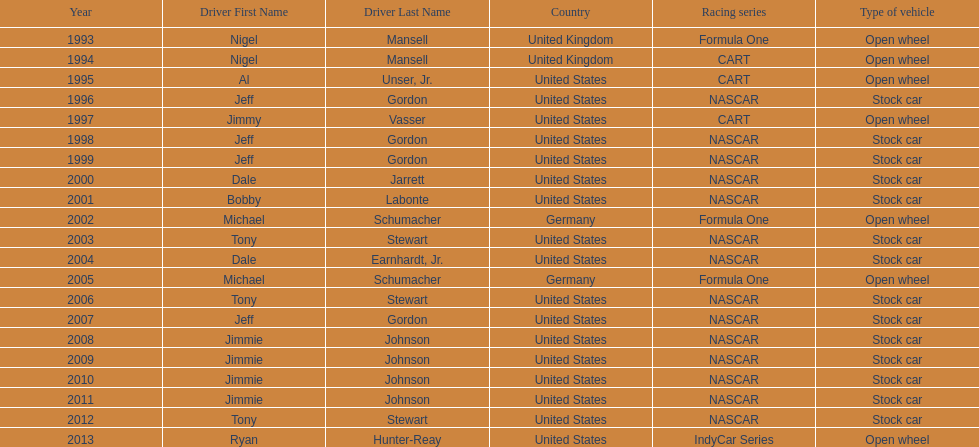Write the full table. {'header': ['Year', 'Driver First Name', 'Driver Last Name', 'Country', 'Racing series', 'Type of vehicle'], 'rows': [['1993', 'Nigel', 'Mansell', 'United Kingdom', 'Formula One', 'Open wheel'], ['1994', 'Nigel', 'Mansell', 'United Kingdom', 'CART', 'Open wheel'], ['1995', 'Al', 'Unser, Jr.', 'United States', 'CART', 'Open wheel'], ['1996', 'Jeff', 'Gordon', 'United States', 'NASCAR', 'Stock car'], ['1997', 'Jimmy', 'Vasser', 'United States', 'CART', 'Open wheel'], ['1998', 'Jeff', 'Gordon', 'United States', 'NASCAR', 'Stock car'], ['1999', 'Jeff', 'Gordon', 'United States', 'NASCAR', 'Stock car'], ['2000', 'Dale', 'Jarrett', 'United States', 'NASCAR', 'Stock car'], ['2001', 'Bobby', 'Labonte', 'United States', 'NASCAR', 'Stock car'], ['2002', 'Michael', 'Schumacher', 'Germany', 'Formula One', 'Open wheel'], ['2003', 'Tony', 'Stewart', 'United States', 'NASCAR', 'Stock car'], ['2004', 'Dale', 'Earnhardt, Jr.', 'United States', 'NASCAR', 'Stock car'], ['2005', 'Michael', 'Schumacher', 'Germany', 'Formula One', 'Open wheel'], ['2006', 'Tony', 'Stewart', 'United States', 'NASCAR', 'Stock car'], ['2007', 'Jeff', 'Gordon', 'United States', 'NASCAR', 'Stock car'], ['2008', 'Jimmie', 'Johnson', 'United States', 'NASCAR', 'Stock car'], ['2009', 'Jimmie', 'Johnson', 'United States', 'NASCAR', 'Stock car'], ['2010', 'Jimmie', 'Johnson', 'United States', 'NASCAR', 'Stock car'], ['2011', 'Jimmie', 'Johnson', 'United States', 'NASCAR', 'Stock car'], ['2012', 'Tony', 'Stewart', 'United States', 'NASCAR', 'Stock car'], ['2013', 'Ryan', 'Hunter-Reay', 'United States', 'IndyCar Series', 'Open wheel']]} Which driver had four consecutive wins? Jimmie Johnson. 